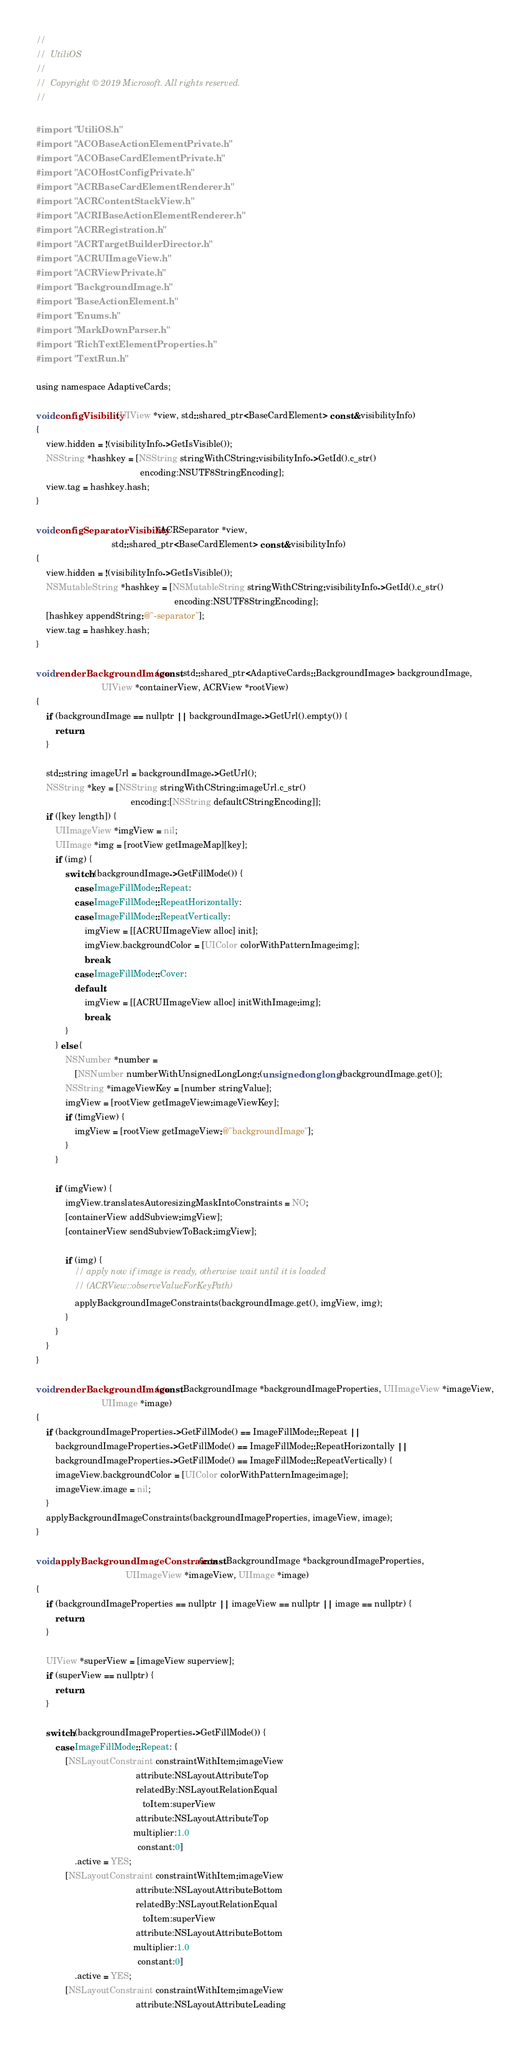Convert code to text. <code><loc_0><loc_0><loc_500><loc_500><_ObjectiveC_>//
//  UtiliOS
//
//  Copyright © 2019 Microsoft. All rights reserved.
//

#import "UtiliOS.h"
#import "ACOBaseActionElementPrivate.h"
#import "ACOBaseCardElementPrivate.h"
#import "ACOHostConfigPrivate.h"
#import "ACRBaseCardElementRenderer.h"
#import "ACRContentStackView.h"
#import "ACRIBaseActionElementRenderer.h"
#import "ACRRegistration.h"
#import "ACRTargetBuilderDirector.h"
#import "ACRUIImageView.h"
#import "ACRViewPrivate.h"
#import "BackgroundImage.h"
#import "BaseActionElement.h"
#import "Enums.h"
#import "MarkDownParser.h"
#import "RichTextElementProperties.h"
#import "TextRun.h"

using namespace AdaptiveCards;

void configVisibility(UIView *view, std::shared_ptr<BaseCardElement> const &visibilityInfo)
{
    view.hidden = !(visibilityInfo->GetIsVisible());
    NSString *hashkey = [NSString stringWithCString:visibilityInfo->GetId().c_str()
                                           encoding:NSUTF8StringEncoding];
    view.tag = hashkey.hash;
}

void configSeparatorVisibility(ACRSeparator *view,
                               std::shared_ptr<BaseCardElement> const &visibilityInfo)
{
    view.hidden = !(visibilityInfo->GetIsVisible());
    NSMutableString *hashkey = [NSMutableString stringWithCString:visibilityInfo->GetId().c_str()
                                                         encoding:NSUTF8StringEncoding];
    [hashkey appendString:@"-separator"];
    view.tag = hashkey.hash;
}

void renderBackgroundImage(const std::shared_ptr<AdaptiveCards::BackgroundImage> backgroundImage,
                           UIView *containerView, ACRView *rootView)
{
    if (backgroundImage == nullptr || backgroundImage->GetUrl().empty()) {
        return;
    }

    std::string imageUrl = backgroundImage->GetUrl();
    NSString *key = [NSString stringWithCString:imageUrl.c_str()
                                       encoding:[NSString defaultCStringEncoding]];
    if ([key length]) {
        UIImageView *imgView = nil;
        UIImage *img = [rootView getImageMap][key];
        if (img) {
            switch (backgroundImage->GetFillMode()) {
                case ImageFillMode::Repeat:
                case ImageFillMode::RepeatHorizontally:
                case ImageFillMode::RepeatVertically:
                    imgView = [[ACRUIImageView alloc] init];
                    imgView.backgroundColor = [UIColor colorWithPatternImage:img];
                    break;
                case ImageFillMode::Cover:
                default:
                    imgView = [[ACRUIImageView alloc] initWithImage:img];
                    break;
            }
        } else {
            NSNumber *number =
                [NSNumber numberWithUnsignedLongLong:(unsigned long long)backgroundImage.get()];
            NSString *imageViewKey = [number stringValue];
            imgView = [rootView getImageView:imageViewKey];
            if (!imgView) {
                imgView = [rootView getImageView:@"backgroundImage"];
            }
        }

        if (imgView) {
            imgView.translatesAutoresizingMaskIntoConstraints = NO;
            [containerView addSubview:imgView];
            [containerView sendSubviewToBack:imgView];

            if (img) {
                // apply now if image is ready, otherwise wait until it is loaded
                // (ACRView::observeValueForKeyPath)
                applyBackgroundImageConstraints(backgroundImage.get(), imgView, img);
            }
        }
    }
}

void renderBackgroundImage(const BackgroundImage *backgroundImageProperties, UIImageView *imageView,
                           UIImage *image)
{
    if (backgroundImageProperties->GetFillMode() == ImageFillMode::Repeat ||
        backgroundImageProperties->GetFillMode() == ImageFillMode::RepeatHorizontally ||
        backgroundImageProperties->GetFillMode() == ImageFillMode::RepeatVertically) {
        imageView.backgroundColor = [UIColor colorWithPatternImage:image];
        imageView.image = nil;
    }
    applyBackgroundImageConstraints(backgroundImageProperties, imageView, image);
}

void applyBackgroundImageConstraints(const BackgroundImage *backgroundImageProperties,
                                     UIImageView *imageView, UIImage *image)
{
    if (backgroundImageProperties == nullptr || imageView == nullptr || image == nullptr) {
        return;
    }

    UIView *superView = [imageView superview];
    if (superView == nullptr) {
        return;
    }

    switch (backgroundImageProperties->GetFillMode()) {
        case ImageFillMode::Repeat: {
            [NSLayoutConstraint constraintWithItem:imageView
                                         attribute:NSLayoutAttributeTop
                                         relatedBy:NSLayoutRelationEqual
                                            toItem:superView
                                         attribute:NSLayoutAttributeTop
                                        multiplier:1.0
                                          constant:0]
                .active = YES;
            [NSLayoutConstraint constraintWithItem:imageView
                                         attribute:NSLayoutAttributeBottom
                                         relatedBy:NSLayoutRelationEqual
                                            toItem:superView
                                         attribute:NSLayoutAttributeBottom
                                        multiplier:1.0
                                          constant:0]
                .active = YES;
            [NSLayoutConstraint constraintWithItem:imageView
                                         attribute:NSLayoutAttributeLeading</code> 